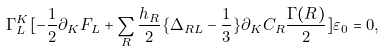Convert formula to latex. <formula><loc_0><loc_0><loc_500><loc_500>\Gamma _ { L } ^ { K } [ - \frac { 1 } { 2 } \partial _ { K } F _ { L } + \sum _ { R } \frac { h _ { R } } { 2 } \{ \Delta _ { R L } - \frac { 1 } { 3 } \} \partial _ { K } C _ { R } \frac { \Gamma ( R ) } { 2 } ] \varepsilon _ { 0 } = 0 ,</formula> 